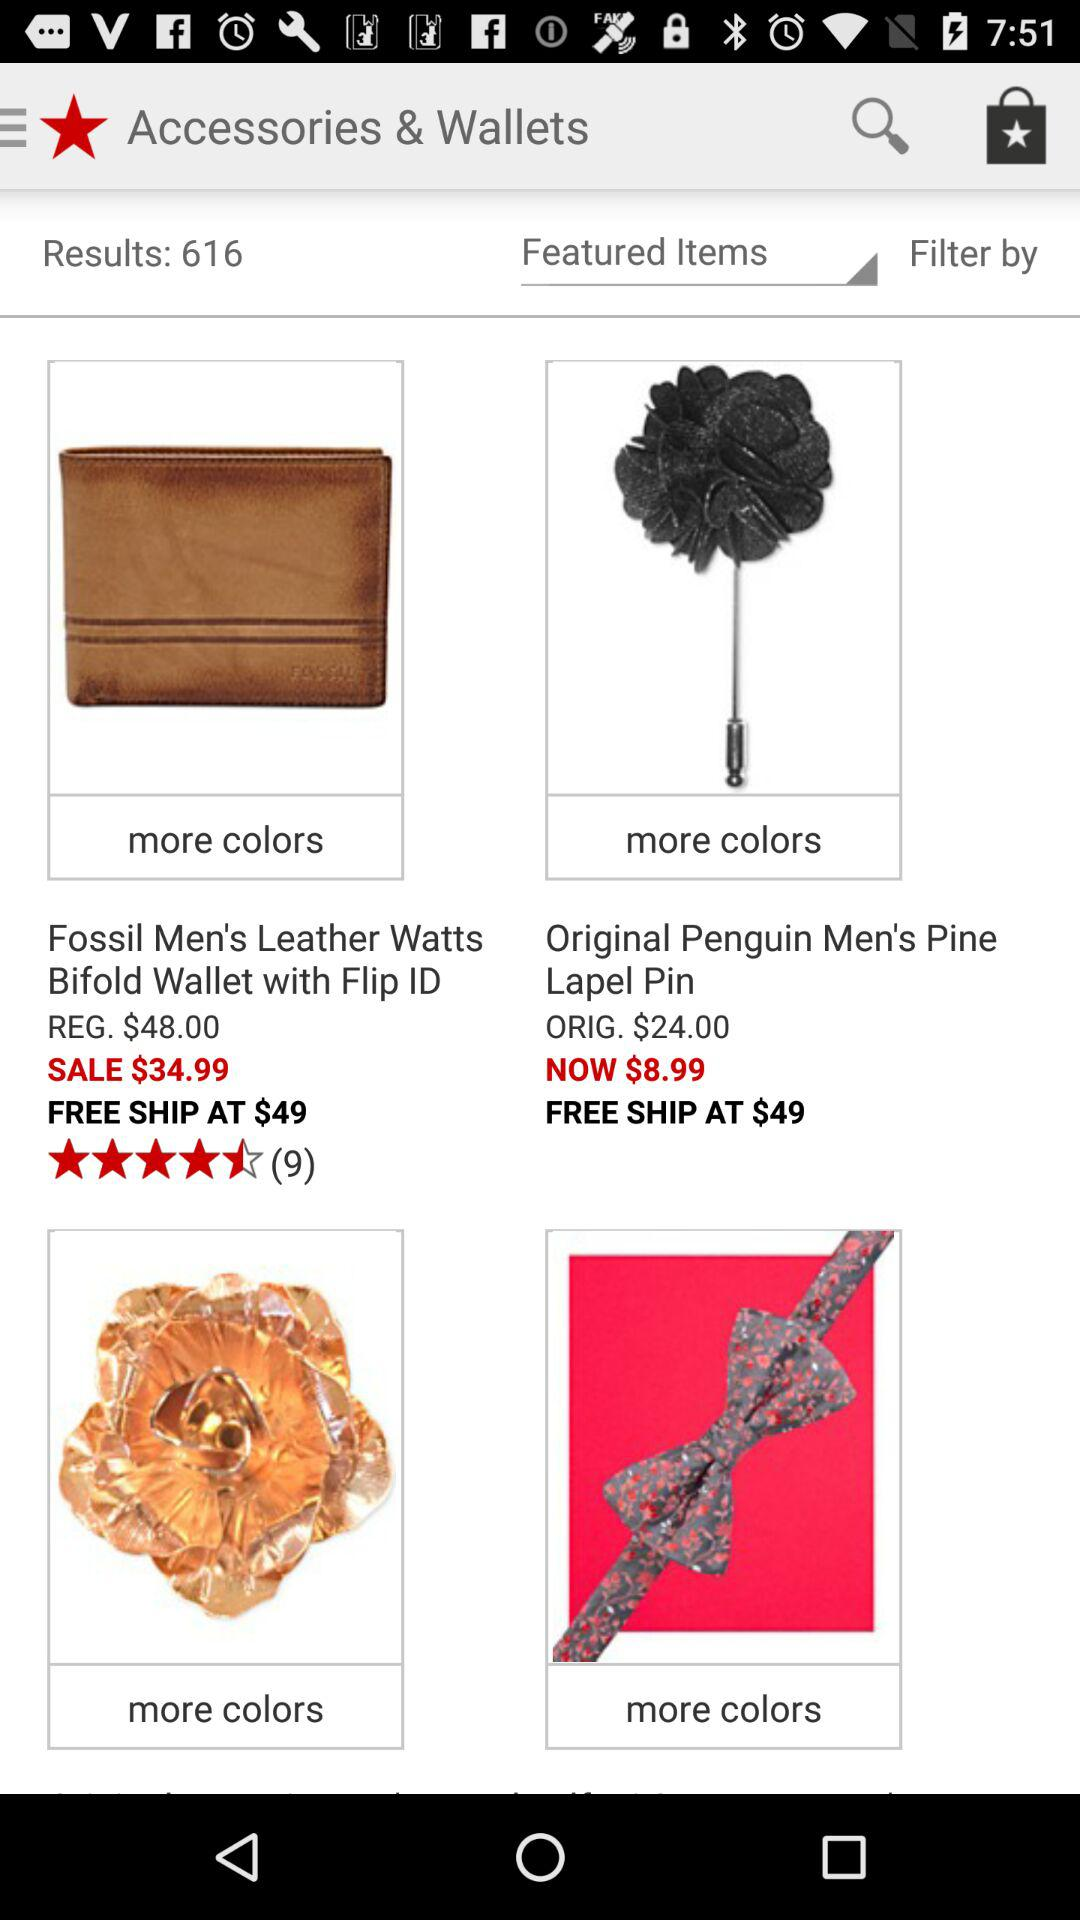Which option is selected? The selected option is "Featured Items". 